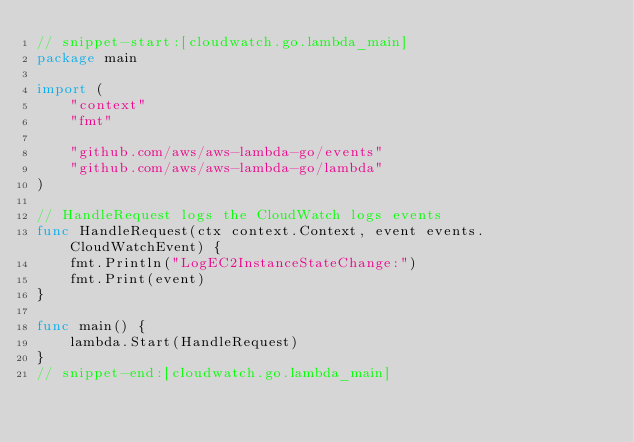Convert code to text. <code><loc_0><loc_0><loc_500><loc_500><_Go_>// snippet-start:[cloudwatch.go.lambda_main]
package main

import (
    "context"
    "fmt"

    "github.com/aws/aws-lambda-go/events"
    "github.com/aws/aws-lambda-go/lambda"
)

// HandleRequest logs the CloudWatch logs events
func HandleRequest(ctx context.Context, event events.CloudWatchEvent) {
    fmt.Println("LogEC2InstanceStateChange:")
    fmt.Print(event)
}

func main() {
    lambda.Start(HandleRequest)
}
// snippet-end:[cloudwatch.go.lambda_main]
</code> 